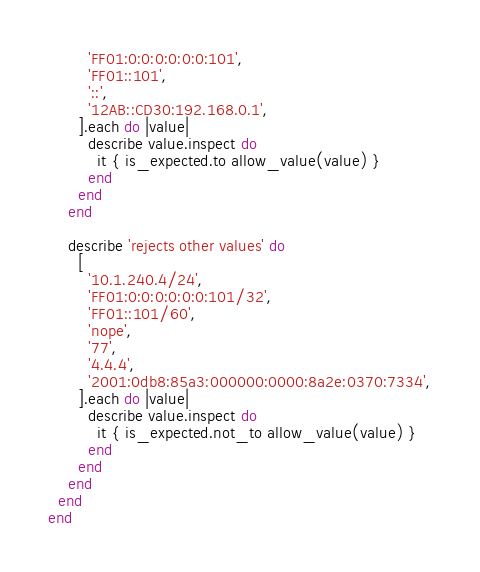Convert code to text. <code><loc_0><loc_0><loc_500><loc_500><_Ruby_>        'FF01:0:0:0:0:0:0:101',
        'FF01::101',
        '::',
        '12AB::CD30:192.168.0.1',
      ].each do |value|
        describe value.inspect do
          it { is_expected.to allow_value(value) }
        end
      end
    end

    describe 'rejects other values' do
      [
        '10.1.240.4/24',
        'FF01:0:0:0:0:0:0:101/32',
        'FF01::101/60',
        'nope',
        '77',
        '4.4.4',
        '2001:0db8:85a3:000000:0000:8a2e:0370:7334',
      ].each do |value|
        describe value.inspect do
          it { is_expected.not_to allow_value(value) }
        end
      end
    end
  end
end
</code> 